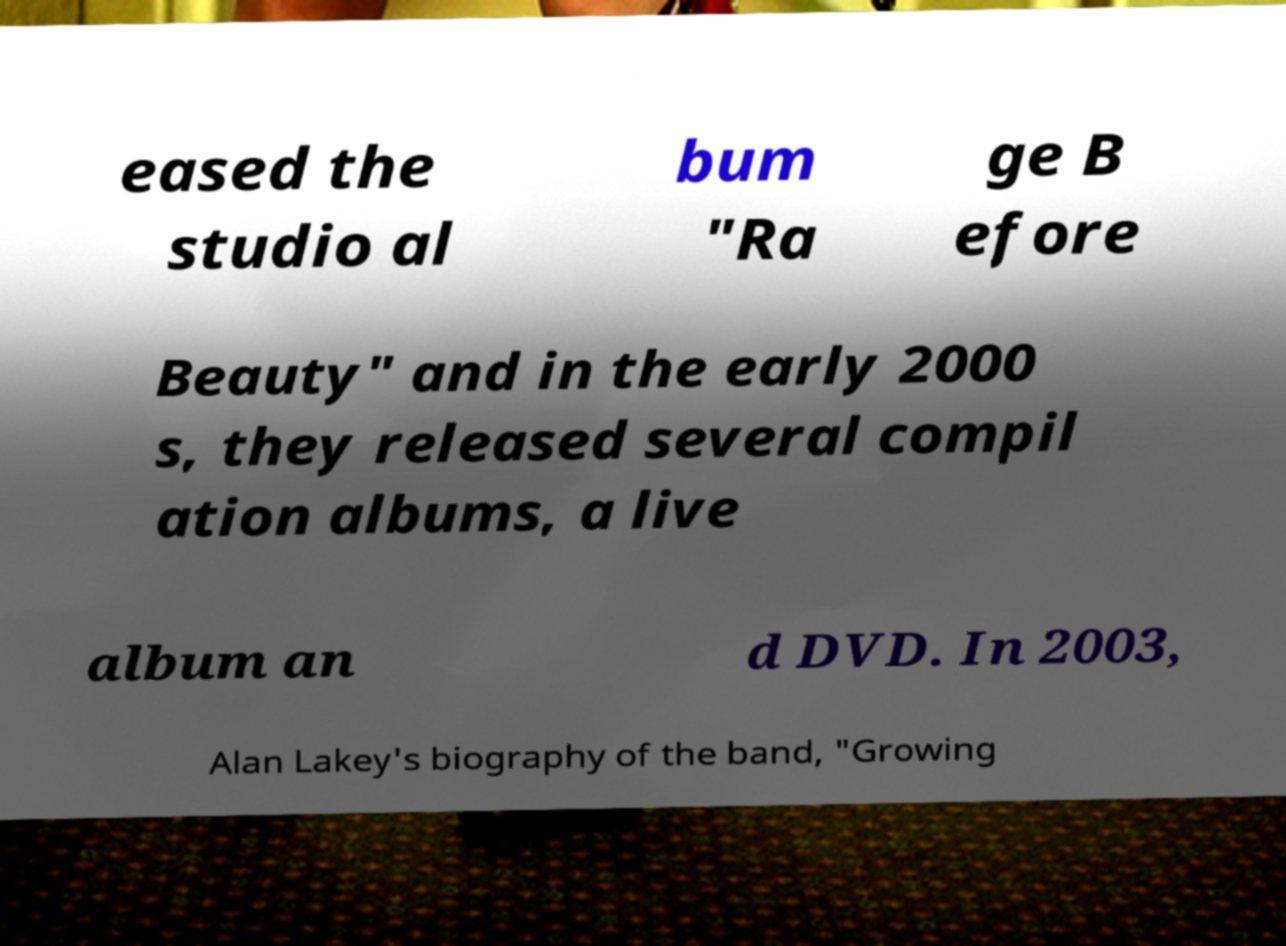For documentation purposes, I need the text within this image transcribed. Could you provide that? eased the studio al bum "Ra ge B efore Beauty" and in the early 2000 s, they released several compil ation albums, a live album an d DVD. In 2003, Alan Lakey's biography of the band, "Growing 